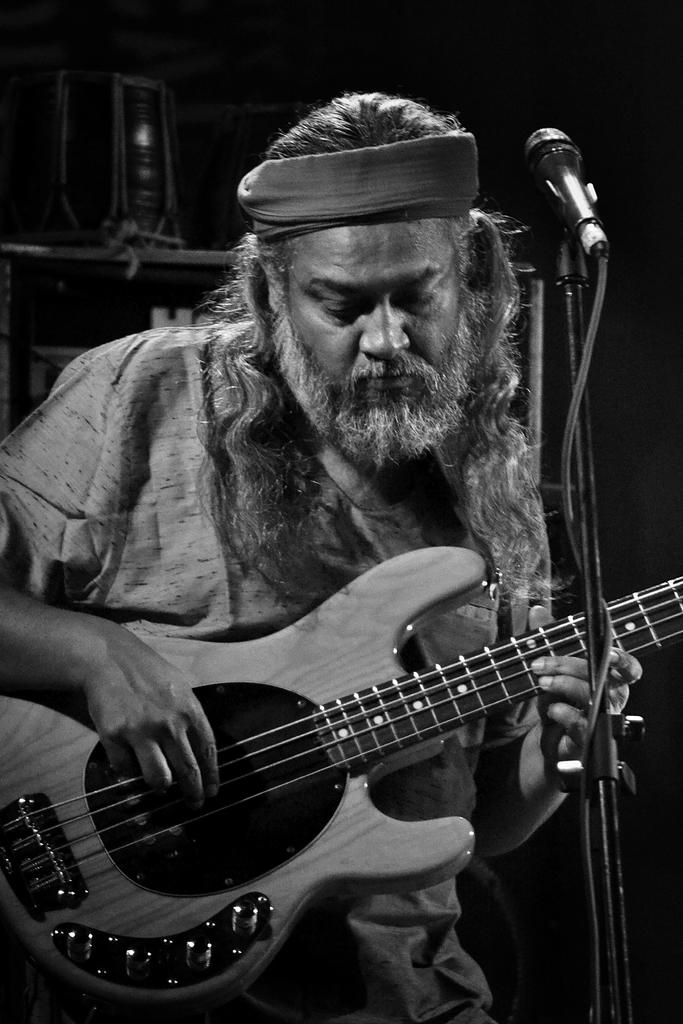What is the man in the image doing? The man is playing a guitar. What object is in front of the man? There is a microphone in front of the man. What can be seen in the background of the image? There are musical instruments in the background of the image. What type of eggnog is being served at the gate in the image? There is no eggnog or gate present in the image. What items are on the list that the man is holding in the image? There is no list present in the image. 